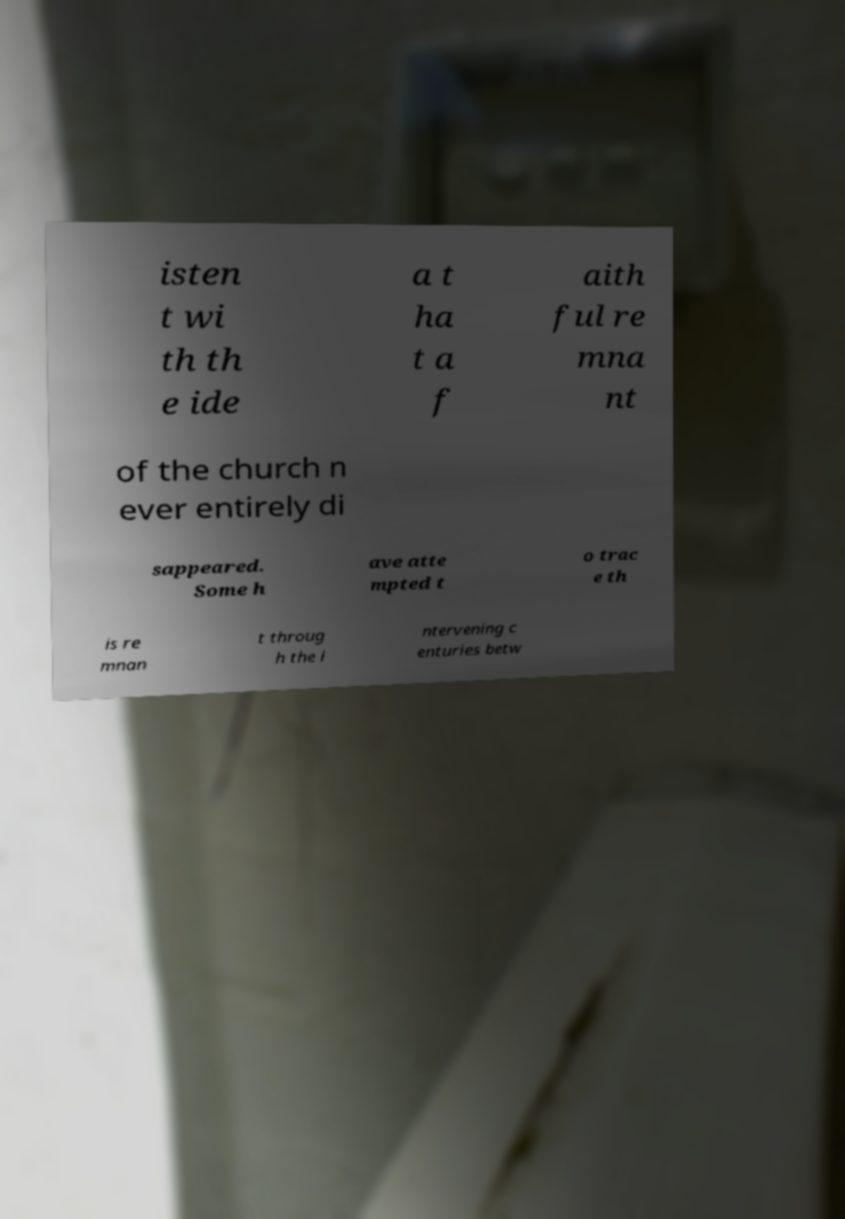What messages or text are displayed in this image? I need them in a readable, typed format. isten t wi th th e ide a t ha t a f aith ful re mna nt of the church n ever entirely di sappeared. Some h ave atte mpted t o trac e th is re mnan t throug h the i ntervening c enturies betw 